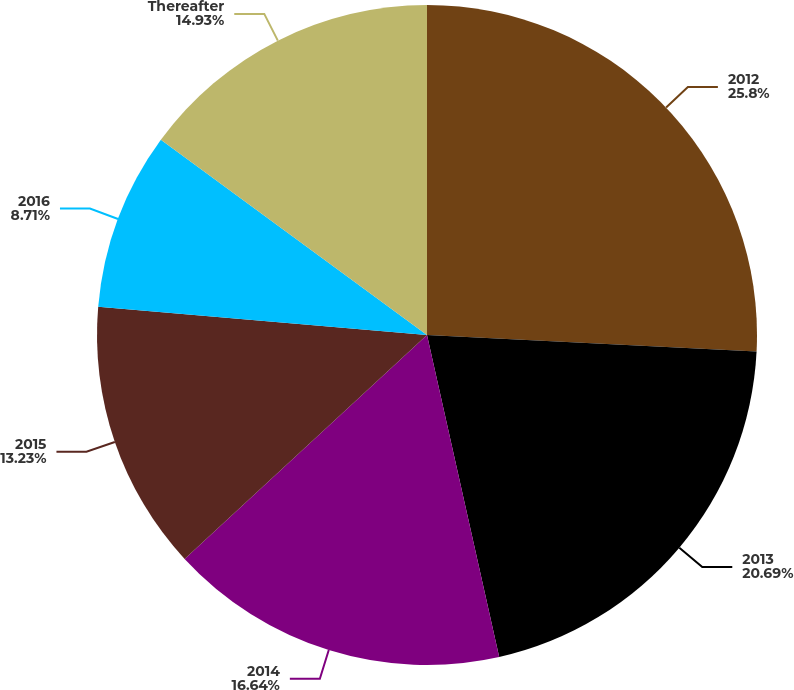<chart> <loc_0><loc_0><loc_500><loc_500><pie_chart><fcel>2012<fcel>2013<fcel>2014<fcel>2015<fcel>2016<fcel>Thereafter<nl><fcel>25.8%<fcel>20.69%<fcel>16.64%<fcel>13.23%<fcel>8.71%<fcel>14.93%<nl></chart> 